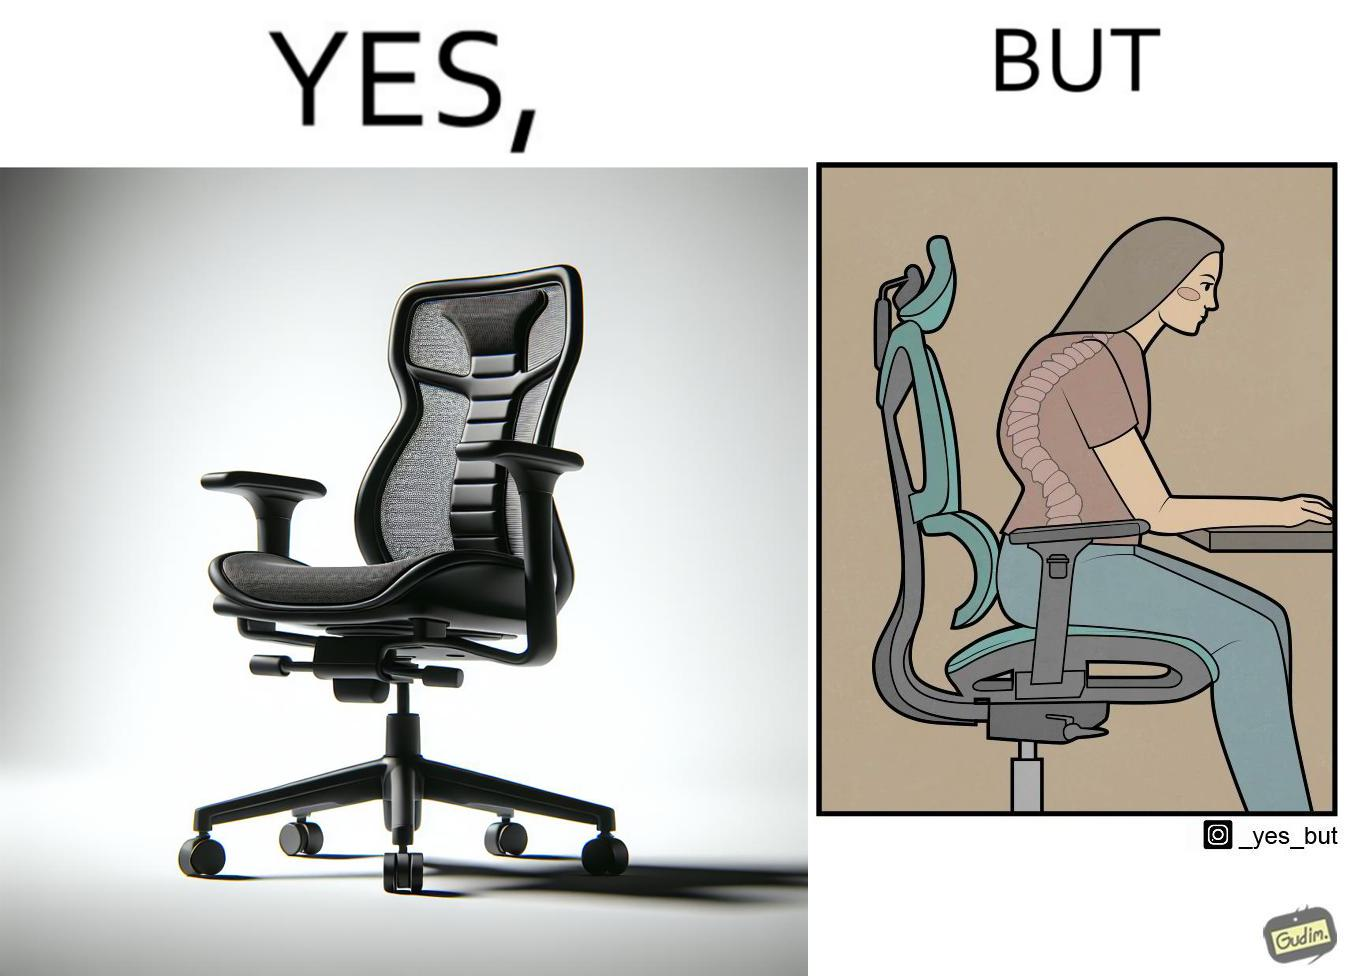Does this image contain satire or humor? Yes, this image is satirical. 